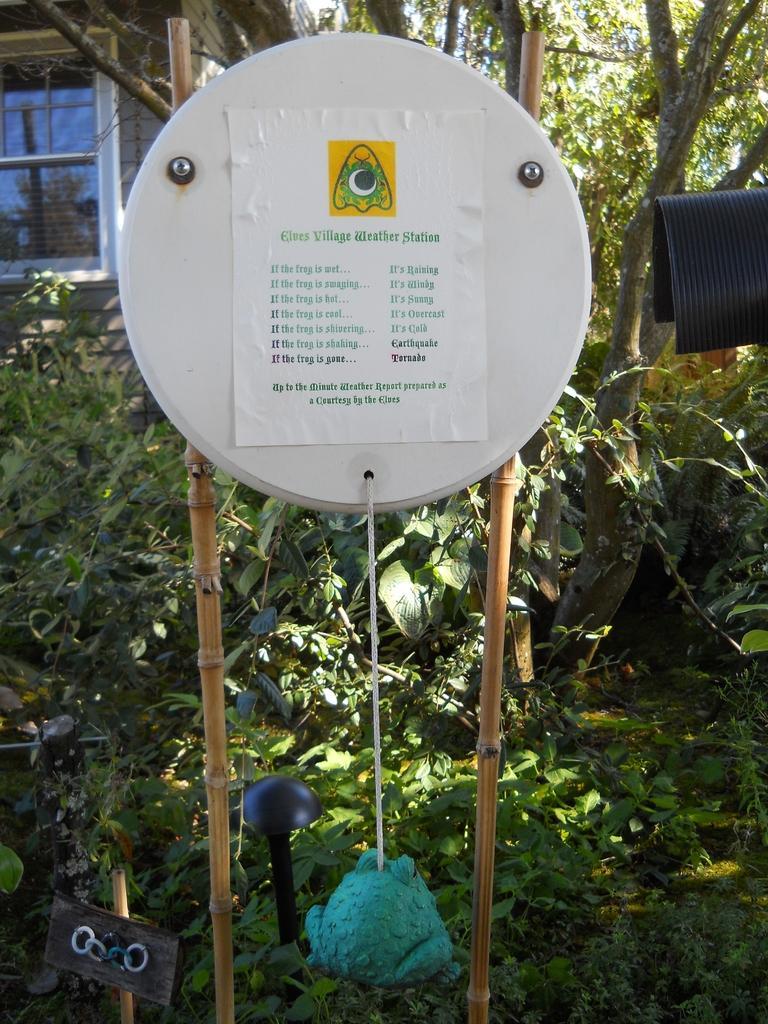Please provide a concise description of this image. In this picture we can see a poster on a board and plants, some objects on the ground and in the background we can see a wall with a window and trees. 